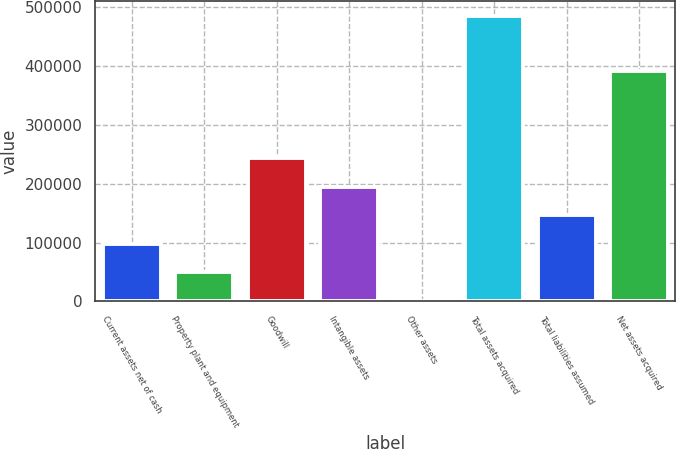Convert chart to OTSL. <chart><loc_0><loc_0><loc_500><loc_500><bar_chart><fcel>Current assets net of cash<fcel>Property plant and equipment<fcel>Goodwill<fcel>Intangible assets<fcel>Other assets<fcel>Total assets acquired<fcel>Total liabilities assumed<fcel>Net assets acquired<nl><fcel>97767.4<fcel>49283.7<fcel>244519<fcel>194735<fcel>800<fcel>485637<fcel>146251<fcel>391371<nl></chart> 